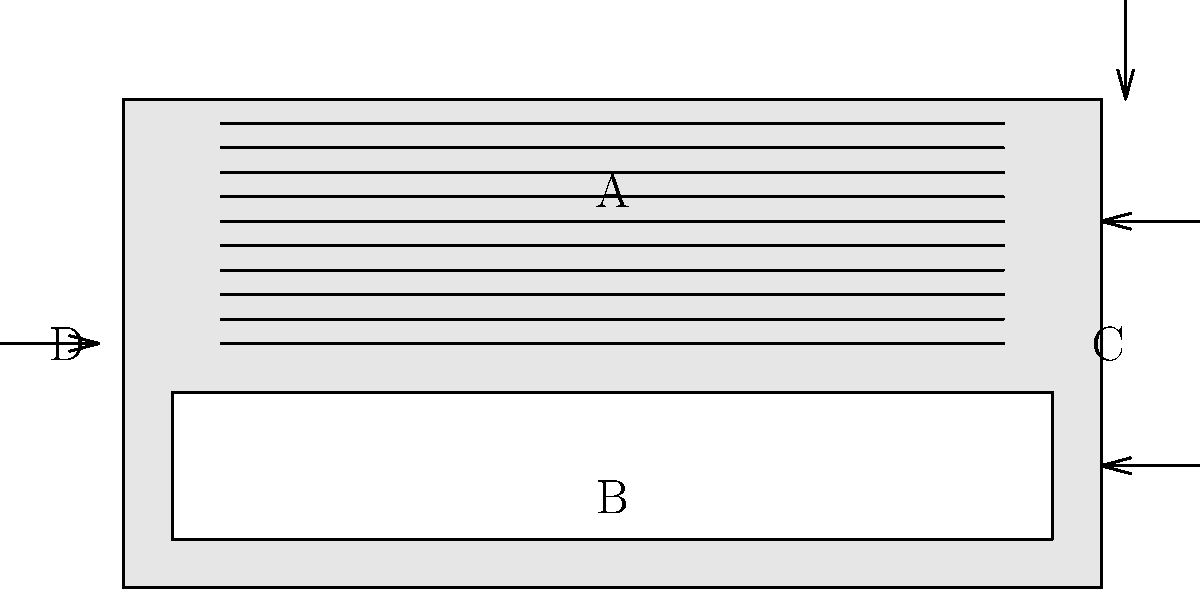As a conductor of a baroque orchestra, you're familiar with various instruments. In the diagram of a harpsichord above, what does label "C" represent? To answer this question, let's analyze the diagram and identify the parts of the harpsichord:

1. The diagram shows a simplified top view of a harpsichord.
2. Label A points to the main body of the instrument, where the strings are located.
3. Label B indicates the keyboard area, where the keys are pressed to play the instrument.
4. Label C is pointing to the right side of the instrument, perpendicular to the strings.
5. Label D is pointing to the left side of the instrument.

Given your expertise as a conductor of a baroque orchestra, you should recognize that the part labeled "C" represents the bridge of the harpsichord. The bridge is a crucial component that transmits the vibrations of the strings to the soundboard, amplifying the sound produced when the keys are pressed.

The bridge is typically located near the end of the strings, perpendicular to them, which matches the position of label C in the diagram.
Answer: Bridge 